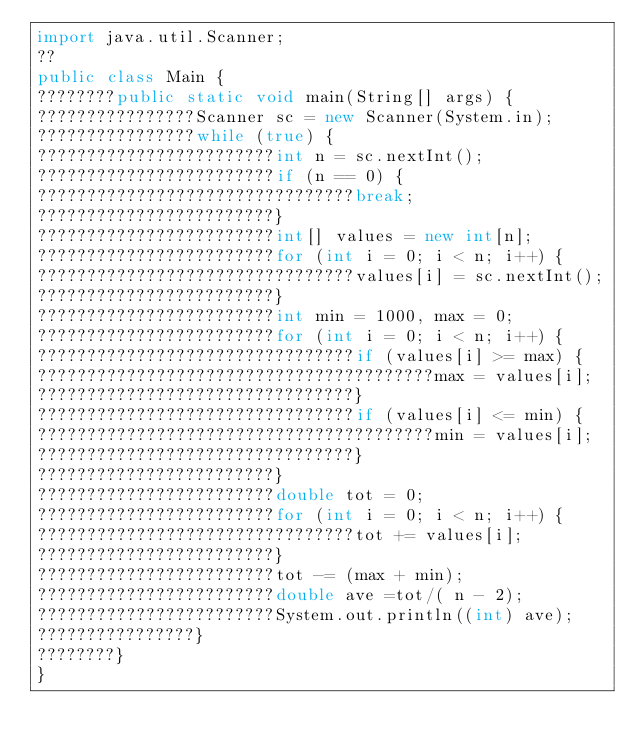<code> <loc_0><loc_0><loc_500><loc_500><_Java_>import java.util.Scanner;
??
public class Main {
????????public static void main(String[] args) {
????????????????Scanner sc = new Scanner(System.in);
????????????????while (true) {
????????????????????????int n = sc.nextInt();
????????????????????????if (n == 0) {
????????????????????????????????break;
????????????????????????}
????????????????????????int[] values = new int[n];
????????????????????????for (int i = 0; i < n; i++) {
????????????????????????????????values[i] = sc.nextInt();
????????????????????????}
????????????????????????int min = 1000, max = 0;
????????????????????????for (int i = 0; i < n; i++) {
????????????????????????????????if (values[i] >= max) {
????????????????????????????????????????max = values[i];
????????????????????????????????}
????????????????????????????????if (values[i] <= min) {
????????????????????????????????????????min = values[i];
????????????????????????????????}
????????????????????????}
????????????????????????double tot = 0;
????????????????????????for (int i = 0; i < n; i++) {
????????????????????????????????tot += values[i];
????????????????????????}
????????????????????????tot -= (max + min);
????????????????????????double ave =tot/( n - 2);
????????????????????????System.out.println((int) ave);
????????????????}
????????}
}</code> 